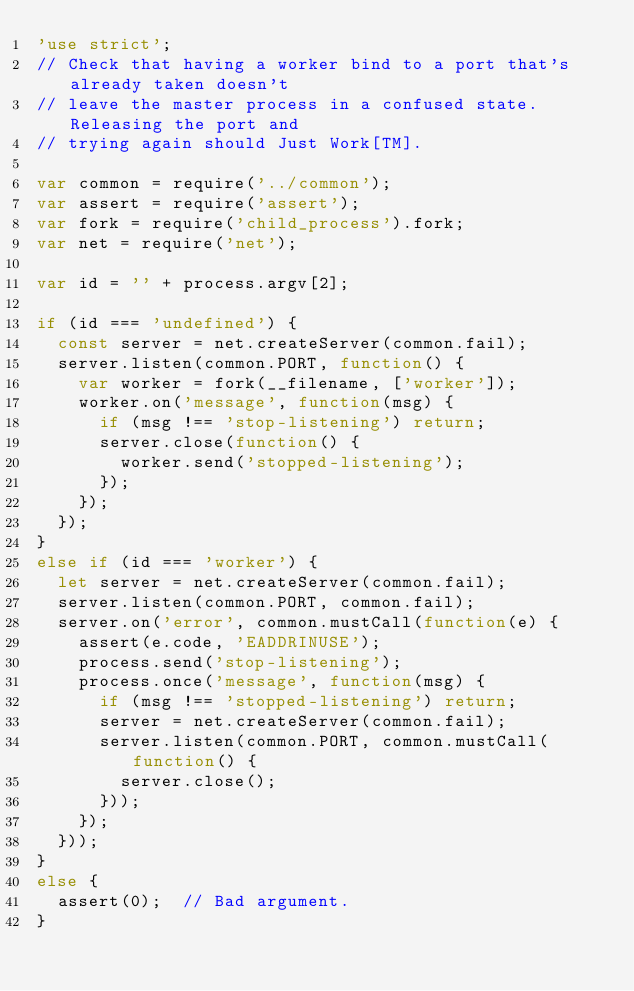<code> <loc_0><loc_0><loc_500><loc_500><_JavaScript_>'use strict';
// Check that having a worker bind to a port that's already taken doesn't
// leave the master process in a confused state. Releasing the port and
// trying again should Just Work[TM].

var common = require('../common');
var assert = require('assert');
var fork = require('child_process').fork;
var net = require('net');

var id = '' + process.argv[2];

if (id === 'undefined') {
  const server = net.createServer(common.fail);
  server.listen(common.PORT, function() {
    var worker = fork(__filename, ['worker']);
    worker.on('message', function(msg) {
      if (msg !== 'stop-listening') return;
      server.close(function() {
        worker.send('stopped-listening');
      });
    });
  });
}
else if (id === 'worker') {
  let server = net.createServer(common.fail);
  server.listen(common.PORT, common.fail);
  server.on('error', common.mustCall(function(e) {
    assert(e.code, 'EADDRINUSE');
    process.send('stop-listening');
    process.once('message', function(msg) {
      if (msg !== 'stopped-listening') return;
      server = net.createServer(common.fail);
      server.listen(common.PORT, common.mustCall(function() {
        server.close();
      }));
    });
  }));
}
else {
  assert(0);  // Bad argument.
}
</code> 